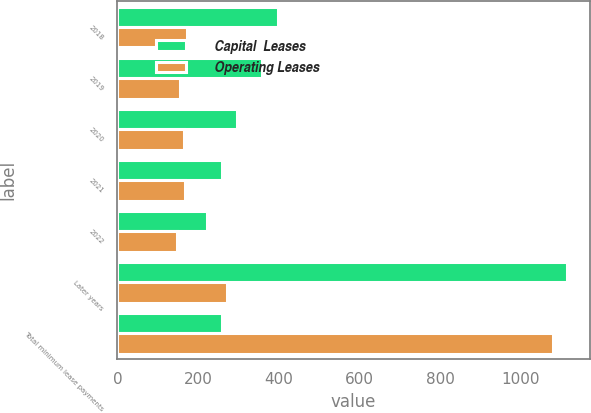<chart> <loc_0><loc_0><loc_500><loc_500><stacked_bar_chart><ecel><fcel>2018<fcel>2019<fcel>2020<fcel>2021<fcel>2022<fcel>Later years<fcel>Total minimum lease payments<nl><fcel>Capital  Leases<fcel>398<fcel>359<fcel>297<fcel>259<fcel>221<fcel>1115<fcel>259<nl><fcel>Operating Leases<fcel>173<fcel>156<fcel>164<fcel>168<fcel>147<fcel>271<fcel>1079<nl></chart> 